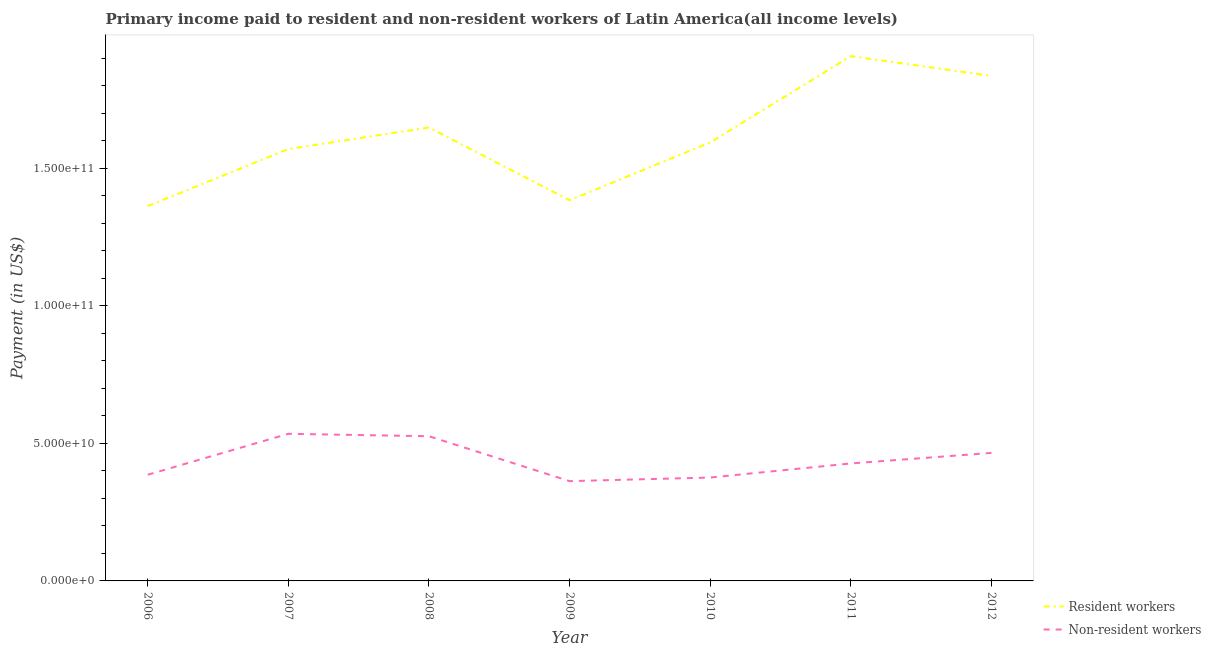What is the payment made to non-resident workers in 2009?
Give a very brief answer. 3.63e+1. Across all years, what is the maximum payment made to resident workers?
Give a very brief answer. 1.91e+11. Across all years, what is the minimum payment made to non-resident workers?
Provide a succinct answer. 3.63e+1. In which year was the payment made to non-resident workers maximum?
Make the answer very short. 2007. What is the total payment made to non-resident workers in the graph?
Your answer should be very brief. 3.08e+11. What is the difference between the payment made to non-resident workers in 2007 and that in 2010?
Provide a succinct answer. 1.59e+1. What is the difference between the payment made to non-resident workers in 2011 and the payment made to resident workers in 2006?
Give a very brief answer. -9.35e+1. What is the average payment made to resident workers per year?
Your answer should be very brief. 1.61e+11. In the year 2012, what is the difference between the payment made to non-resident workers and payment made to resident workers?
Your response must be concise. -1.37e+11. What is the ratio of the payment made to non-resident workers in 2006 to that in 2012?
Keep it short and to the point. 0.83. What is the difference between the highest and the second highest payment made to resident workers?
Make the answer very short. 7.20e+09. What is the difference between the highest and the lowest payment made to resident workers?
Provide a succinct answer. 5.45e+1. In how many years, is the payment made to resident workers greater than the average payment made to resident workers taken over all years?
Your response must be concise. 3. Is the payment made to non-resident workers strictly greater than the payment made to resident workers over the years?
Provide a succinct answer. No. Is the payment made to resident workers strictly less than the payment made to non-resident workers over the years?
Keep it short and to the point. No. What is the difference between two consecutive major ticks on the Y-axis?
Offer a terse response. 5.00e+1. Are the values on the major ticks of Y-axis written in scientific E-notation?
Your response must be concise. Yes. Does the graph contain any zero values?
Ensure brevity in your answer.  No. Does the graph contain grids?
Your response must be concise. No. What is the title of the graph?
Your response must be concise. Primary income paid to resident and non-resident workers of Latin America(all income levels). Does "Study and work" appear as one of the legend labels in the graph?
Offer a very short reply. No. What is the label or title of the X-axis?
Your answer should be compact. Year. What is the label or title of the Y-axis?
Offer a very short reply. Payment (in US$). What is the Payment (in US$) of Resident workers in 2006?
Provide a short and direct response. 1.36e+11. What is the Payment (in US$) of Non-resident workers in 2006?
Provide a short and direct response. 3.86e+1. What is the Payment (in US$) of Resident workers in 2007?
Make the answer very short. 1.57e+11. What is the Payment (in US$) of Non-resident workers in 2007?
Give a very brief answer. 5.35e+1. What is the Payment (in US$) of Resident workers in 2008?
Provide a short and direct response. 1.65e+11. What is the Payment (in US$) in Non-resident workers in 2008?
Ensure brevity in your answer.  5.26e+1. What is the Payment (in US$) of Resident workers in 2009?
Offer a very short reply. 1.38e+11. What is the Payment (in US$) in Non-resident workers in 2009?
Ensure brevity in your answer.  3.63e+1. What is the Payment (in US$) of Resident workers in 2010?
Your answer should be compact. 1.59e+11. What is the Payment (in US$) of Non-resident workers in 2010?
Offer a terse response. 3.76e+1. What is the Payment (in US$) of Resident workers in 2011?
Keep it short and to the point. 1.91e+11. What is the Payment (in US$) of Non-resident workers in 2011?
Provide a short and direct response. 4.27e+1. What is the Payment (in US$) in Resident workers in 2012?
Your response must be concise. 1.83e+11. What is the Payment (in US$) in Non-resident workers in 2012?
Make the answer very short. 4.65e+1. Across all years, what is the maximum Payment (in US$) of Resident workers?
Offer a terse response. 1.91e+11. Across all years, what is the maximum Payment (in US$) of Non-resident workers?
Provide a short and direct response. 5.35e+1. Across all years, what is the minimum Payment (in US$) in Resident workers?
Keep it short and to the point. 1.36e+11. Across all years, what is the minimum Payment (in US$) of Non-resident workers?
Offer a very short reply. 3.63e+1. What is the total Payment (in US$) of Resident workers in the graph?
Provide a short and direct response. 1.13e+12. What is the total Payment (in US$) in Non-resident workers in the graph?
Give a very brief answer. 3.08e+11. What is the difference between the Payment (in US$) of Resident workers in 2006 and that in 2007?
Your answer should be very brief. -2.07e+1. What is the difference between the Payment (in US$) of Non-resident workers in 2006 and that in 2007?
Offer a very short reply. -1.49e+1. What is the difference between the Payment (in US$) in Resident workers in 2006 and that in 2008?
Make the answer very short. -2.86e+1. What is the difference between the Payment (in US$) in Non-resident workers in 2006 and that in 2008?
Offer a very short reply. -1.40e+1. What is the difference between the Payment (in US$) in Resident workers in 2006 and that in 2009?
Give a very brief answer. -2.14e+09. What is the difference between the Payment (in US$) in Non-resident workers in 2006 and that in 2009?
Offer a very short reply. 2.33e+09. What is the difference between the Payment (in US$) of Resident workers in 2006 and that in 2010?
Make the answer very short. -2.31e+1. What is the difference between the Payment (in US$) in Non-resident workers in 2006 and that in 2010?
Provide a short and direct response. 1.02e+09. What is the difference between the Payment (in US$) in Resident workers in 2006 and that in 2011?
Give a very brief answer. -5.45e+1. What is the difference between the Payment (in US$) of Non-resident workers in 2006 and that in 2011?
Ensure brevity in your answer.  -4.10e+09. What is the difference between the Payment (in US$) in Resident workers in 2006 and that in 2012?
Ensure brevity in your answer.  -4.73e+1. What is the difference between the Payment (in US$) of Non-resident workers in 2006 and that in 2012?
Your answer should be compact. -7.93e+09. What is the difference between the Payment (in US$) in Resident workers in 2007 and that in 2008?
Keep it short and to the point. -7.83e+09. What is the difference between the Payment (in US$) of Non-resident workers in 2007 and that in 2008?
Your response must be concise. 8.77e+08. What is the difference between the Payment (in US$) in Resident workers in 2007 and that in 2009?
Provide a short and direct response. 1.86e+1. What is the difference between the Payment (in US$) in Non-resident workers in 2007 and that in 2009?
Keep it short and to the point. 1.72e+1. What is the difference between the Payment (in US$) in Resident workers in 2007 and that in 2010?
Offer a very short reply. -2.41e+09. What is the difference between the Payment (in US$) in Non-resident workers in 2007 and that in 2010?
Provide a short and direct response. 1.59e+1. What is the difference between the Payment (in US$) of Resident workers in 2007 and that in 2011?
Provide a succinct answer. -3.38e+1. What is the difference between the Payment (in US$) of Non-resident workers in 2007 and that in 2011?
Give a very brief answer. 1.08e+1. What is the difference between the Payment (in US$) in Resident workers in 2007 and that in 2012?
Give a very brief answer. -2.66e+1. What is the difference between the Payment (in US$) of Non-resident workers in 2007 and that in 2012?
Your answer should be very brief. 6.94e+09. What is the difference between the Payment (in US$) of Resident workers in 2008 and that in 2009?
Offer a very short reply. 2.64e+1. What is the difference between the Payment (in US$) of Non-resident workers in 2008 and that in 2009?
Your response must be concise. 1.63e+1. What is the difference between the Payment (in US$) of Resident workers in 2008 and that in 2010?
Make the answer very short. 5.42e+09. What is the difference between the Payment (in US$) in Non-resident workers in 2008 and that in 2010?
Offer a terse response. 1.50e+1. What is the difference between the Payment (in US$) in Resident workers in 2008 and that in 2011?
Your response must be concise. -2.59e+1. What is the difference between the Payment (in US$) of Non-resident workers in 2008 and that in 2011?
Your answer should be very brief. 9.89e+09. What is the difference between the Payment (in US$) of Resident workers in 2008 and that in 2012?
Provide a short and direct response. -1.87e+1. What is the difference between the Payment (in US$) in Non-resident workers in 2008 and that in 2012?
Offer a very short reply. 6.06e+09. What is the difference between the Payment (in US$) of Resident workers in 2009 and that in 2010?
Keep it short and to the point. -2.10e+1. What is the difference between the Payment (in US$) in Non-resident workers in 2009 and that in 2010?
Offer a very short reply. -1.31e+09. What is the difference between the Payment (in US$) in Resident workers in 2009 and that in 2011?
Your response must be concise. -5.24e+1. What is the difference between the Payment (in US$) in Non-resident workers in 2009 and that in 2011?
Offer a terse response. -6.43e+09. What is the difference between the Payment (in US$) of Resident workers in 2009 and that in 2012?
Ensure brevity in your answer.  -4.52e+1. What is the difference between the Payment (in US$) in Non-resident workers in 2009 and that in 2012?
Make the answer very short. -1.03e+1. What is the difference between the Payment (in US$) in Resident workers in 2010 and that in 2011?
Offer a terse response. -3.14e+1. What is the difference between the Payment (in US$) in Non-resident workers in 2010 and that in 2011?
Your answer should be compact. -5.12e+09. What is the difference between the Payment (in US$) in Resident workers in 2010 and that in 2012?
Ensure brevity in your answer.  -2.42e+1. What is the difference between the Payment (in US$) of Non-resident workers in 2010 and that in 2012?
Provide a short and direct response. -8.95e+09. What is the difference between the Payment (in US$) of Resident workers in 2011 and that in 2012?
Offer a very short reply. 7.20e+09. What is the difference between the Payment (in US$) in Non-resident workers in 2011 and that in 2012?
Offer a very short reply. -3.83e+09. What is the difference between the Payment (in US$) of Resident workers in 2006 and the Payment (in US$) of Non-resident workers in 2007?
Your answer should be very brief. 8.27e+1. What is the difference between the Payment (in US$) of Resident workers in 2006 and the Payment (in US$) of Non-resident workers in 2008?
Ensure brevity in your answer.  8.36e+1. What is the difference between the Payment (in US$) in Resident workers in 2006 and the Payment (in US$) in Non-resident workers in 2009?
Offer a terse response. 9.99e+1. What is the difference between the Payment (in US$) in Resident workers in 2006 and the Payment (in US$) in Non-resident workers in 2010?
Keep it short and to the point. 9.86e+1. What is the difference between the Payment (in US$) in Resident workers in 2006 and the Payment (in US$) in Non-resident workers in 2011?
Offer a terse response. 9.35e+1. What is the difference between the Payment (in US$) of Resident workers in 2006 and the Payment (in US$) of Non-resident workers in 2012?
Ensure brevity in your answer.  8.97e+1. What is the difference between the Payment (in US$) in Resident workers in 2007 and the Payment (in US$) in Non-resident workers in 2008?
Keep it short and to the point. 1.04e+11. What is the difference between the Payment (in US$) in Resident workers in 2007 and the Payment (in US$) in Non-resident workers in 2009?
Your answer should be compact. 1.21e+11. What is the difference between the Payment (in US$) in Resident workers in 2007 and the Payment (in US$) in Non-resident workers in 2010?
Keep it short and to the point. 1.19e+11. What is the difference between the Payment (in US$) of Resident workers in 2007 and the Payment (in US$) of Non-resident workers in 2011?
Give a very brief answer. 1.14e+11. What is the difference between the Payment (in US$) of Resident workers in 2007 and the Payment (in US$) of Non-resident workers in 2012?
Your answer should be very brief. 1.10e+11. What is the difference between the Payment (in US$) of Resident workers in 2008 and the Payment (in US$) of Non-resident workers in 2009?
Ensure brevity in your answer.  1.28e+11. What is the difference between the Payment (in US$) in Resident workers in 2008 and the Payment (in US$) in Non-resident workers in 2010?
Provide a short and direct response. 1.27e+11. What is the difference between the Payment (in US$) of Resident workers in 2008 and the Payment (in US$) of Non-resident workers in 2011?
Offer a very short reply. 1.22e+11. What is the difference between the Payment (in US$) of Resident workers in 2008 and the Payment (in US$) of Non-resident workers in 2012?
Offer a very short reply. 1.18e+11. What is the difference between the Payment (in US$) of Resident workers in 2009 and the Payment (in US$) of Non-resident workers in 2010?
Your answer should be very brief. 1.01e+11. What is the difference between the Payment (in US$) of Resident workers in 2009 and the Payment (in US$) of Non-resident workers in 2011?
Keep it short and to the point. 9.56e+1. What is the difference between the Payment (in US$) of Resident workers in 2009 and the Payment (in US$) of Non-resident workers in 2012?
Keep it short and to the point. 9.18e+1. What is the difference between the Payment (in US$) in Resident workers in 2010 and the Payment (in US$) in Non-resident workers in 2011?
Keep it short and to the point. 1.17e+11. What is the difference between the Payment (in US$) of Resident workers in 2010 and the Payment (in US$) of Non-resident workers in 2012?
Give a very brief answer. 1.13e+11. What is the difference between the Payment (in US$) in Resident workers in 2011 and the Payment (in US$) in Non-resident workers in 2012?
Offer a terse response. 1.44e+11. What is the average Payment (in US$) in Resident workers per year?
Your response must be concise. 1.61e+11. What is the average Payment (in US$) of Non-resident workers per year?
Provide a succinct answer. 4.39e+1. In the year 2006, what is the difference between the Payment (in US$) in Resident workers and Payment (in US$) in Non-resident workers?
Keep it short and to the point. 9.76e+1. In the year 2007, what is the difference between the Payment (in US$) of Resident workers and Payment (in US$) of Non-resident workers?
Keep it short and to the point. 1.03e+11. In the year 2008, what is the difference between the Payment (in US$) of Resident workers and Payment (in US$) of Non-resident workers?
Your answer should be very brief. 1.12e+11. In the year 2009, what is the difference between the Payment (in US$) in Resident workers and Payment (in US$) in Non-resident workers?
Offer a very short reply. 1.02e+11. In the year 2010, what is the difference between the Payment (in US$) in Resident workers and Payment (in US$) in Non-resident workers?
Make the answer very short. 1.22e+11. In the year 2011, what is the difference between the Payment (in US$) of Resident workers and Payment (in US$) of Non-resident workers?
Give a very brief answer. 1.48e+11. In the year 2012, what is the difference between the Payment (in US$) of Resident workers and Payment (in US$) of Non-resident workers?
Make the answer very short. 1.37e+11. What is the ratio of the Payment (in US$) in Resident workers in 2006 to that in 2007?
Offer a terse response. 0.87. What is the ratio of the Payment (in US$) of Non-resident workers in 2006 to that in 2007?
Offer a terse response. 0.72. What is the ratio of the Payment (in US$) of Resident workers in 2006 to that in 2008?
Keep it short and to the point. 0.83. What is the ratio of the Payment (in US$) of Non-resident workers in 2006 to that in 2008?
Offer a terse response. 0.73. What is the ratio of the Payment (in US$) in Resident workers in 2006 to that in 2009?
Offer a terse response. 0.98. What is the ratio of the Payment (in US$) of Non-resident workers in 2006 to that in 2009?
Your answer should be compact. 1.06. What is the ratio of the Payment (in US$) of Resident workers in 2006 to that in 2010?
Ensure brevity in your answer.  0.85. What is the ratio of the Payment (in US$) in Non-resident workers in 2006 to that in 2010?
Offer a terse response. 1.03. What is the ratio of the Payment (in US$) in Resident workers in 2006 to that in 2011?
Make the answer very short. 0.71. What is the ratio of the Payment (in US$) in Non-resident workers in 2006 to that in 2011?
Provide a short and direct response. 0.9. What is the ratio of the Payment (in US$) in Resident workers in 2006 to that in 2012?
Give a very brief answer. 0.74. What is the ratio of the Payment (in US$) of Non-resident workers in 2006 to that in 2012?
Give a very brief answer. 0.83. What is the ratio of the Payment (in US$) of Resident workers in 2007 to that in 2008?
Your answer should be compact. 0.95. What is the ratio of the Payment (in US$) of Non-resident workers in 2007 to that in 2008?
Give a very brief answer. 1.02. What is the ratio of the Payment (in US$) in Resident workers in 2007 to that in 2009?
Your response must be concise. 1.13. What is the ratio of the Payment (in US$) in Non-resident workers in 2007 to that in 2009?
Provide a succinct answer. 1.47. What is the ratio of the Payment (in US$) in Resident workers in 2007 to that in 2010?
Provide a succinct answer. 0.98. What is the ratio of the Payment (in US$) in Non-resident workers in 2007 to that in 2010?
Provide a short and direct response. 1.42. What is the ratio of the Payment (in US$) of Resident workers in 2007 to that in 2011?
Your answer should be compact. 0.82. What is the ratio of the Payment (in US$) in Non-resident workers in 2007 to that in 2011?
Your answer should be very brief. 1.25. What is the ratio of the Payment (in US$) of Resident workers in 2007 to that in 2012?
Give a very brief answer. 0.86. What is the ratio of the Payment (in US$) in Non-resident workers in 2007 to that in 2012?
Provide a succinct answer. 1.15. What is the ratio of the Payment (in US$) in Resident workers in 2008 to that in 2009?
Your answer should be very brief. 1.19. What is the ratio of the Payment (in US$) of Non-resident workers in 2008 to that in 2009?
Provide a succinct answer. 1.45. What is the ratio of the Payment (in US$) in Resident workers in 2008 to that in 2010?
Provide a succinct answer. 1.03. What is the ratio of the Payment (in US$) in Non-resident workers in 2008 to that in 2010?
Offer a very short reply. 1.4. What is the ratio of the Payment (in US$) of Resident workers in 2008 to that in 2011?
Offer a very short reply. 0.86. What is the ratio of the Payment (in US$) in Non-resident workers in 2008 to that in 2011?
Your answer should be compact. 1.23. What is the ratio of the Payment (in US$) in Resident workers in 2008 to that in 2012?
Ensure brevity in your answer.  0.9. What is the ratio of the Payment (in US$) in Non-resident workers in 2008 to that in 2012?
Offer a terse response. 1.13. What is the ratio of the Payment (in US$) in Resident workers in 2009 to that in 2010?
Ensure brevity in your answer.  0.87. What is the ratio of the Payment (in US$) in Non-resident workers in 2009 to that in 2010?
Your response must be concise. 0.97. What is the ratio of the Payment (in US$) in Resident workers in 2009 to that in 2011?
Keep it short and to the point. 0.73. What is the ratio of the Payment (in US$) in Non-resident workers in 2009 to that in 2011?
Give a very brief answer. 0.85. What is the ratio of the Payment (in US$) of Resident workers in 2009 to that in 2012?
Your answer should be very brief. 0.75. What is the ratio of the Payment (in US$) in Non-resident workers in 2009 to that in 2012?
Provide a short and direct response. 0.78. What is the ratio of the Payment (in US$) in Resident workers in 2010 to that in 2011?
Keep it short and to the point. 0.84. What is the ratio of the Payment (in US$) of Non-resident workers in 2010 to that in 2011?
Provide a short and direct response. 0.88. What is the ratio of the Payment (in US$) of Resident workers in 2010 to that in 2012?
Your answer should be compact. 0.87. What is the ratio of the Payment (in US$) of Non-resident workers in 2010 to that in 2012?
Offer a very short reply. 0.81. What is the ratio of the Payment (in US$) of Resident workers in 2011 to that in 2012?
Ensure brevity in your answer.  1.04. What is the ratio of the Payment (in US$) of Non-resident workers in 2011 to that in 2012?
Offer a very short reply. 0.92. What is the difference between the highest and the second highest Payment (in US$) in Resident workers?
Your answer should be compact. 7.20e+09. What is the difference between the highest and the second highest Payment (in US$) in Non-resident workers?
Provide a short and direct response. 8.77e+08. What is the difference between the highest and the lowest Payment (in US$) of Resident workers?
Provide a short and direct response. 5.45e+1. What is the difference between the highest and the lowest Payment (in US$) in Non-resident workers?
Keep it short and to the point. 1.72e+1. 